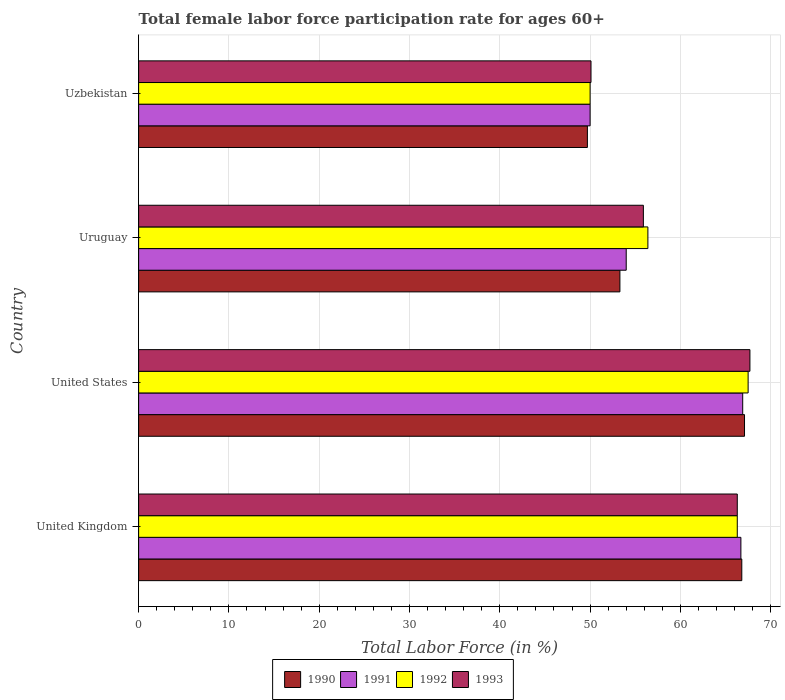Are the number of bars on each tick of the Y-axis equal?
Give a very brief answer. Yes. How many bars are there on the 2nd tick from the top?
Provide a short and direct response. 4. What is the label of the 2nd group of bars from the top?
Keep it short and to the point. Uruguay. In how many cases, is the number of bars for a given country not equal to the number of legend labels?
Provide a succinct answer. 0. What is the female labor force participation rate in 1990 in Uzbekistan?
Your answer should be compact. 49.7. Across all countries, what is the maximum female labor force participation rate in 1993?
Make the answer very short. 67.7. Across all countries, what is the minimum female labor force participation rate in 1993?
Make the answer very short. 50.1. In which country was the female labor force participation rate in 1992 maximum?
Provide a succinct answer. United States. In which country was the female labor force participation rate in 1993 minimum?
Your response must be concise. Uzbekistan. What is the total female labor force participation rate in 1992 in the graph?
Provide a short and direct response. 240.2. What is the difference between the female labor force participation rate in 1993 in United Kingdom and that in United States?
Keep it short and to the point. -1.4. What is the difference between the female labor force participation rate in 1991 in Uzbekistan and the female labor force participation rate in 1990 in United Kingdom?
Provide a short and direct response. -16.8. What is the average female labor force participation rate in 1990 per country?
Make the answer very short. 59.23. What is the difference between the female labor force participation rate in 1990 and female labor force participation rate in 1993 in United States?
Provide a short and direct response. -0.6. What is the ratio of the female labor force participation rate in 1992 in United States to that in Uruguay?
Your answer should be very brief. 1.2. Is the difference between the female labor force participation rate in 1990 in United Kingdom and United States greater than the difference between the female labor force participation rate in 1993 in United Kingdom and United States?
Ensure brevity in your answer.  Yes. What is the difference between the highest and the second highest female labor force participation rate in 1991?
Your answer should be compact. 0.2. What is the difference between the highest and the lowest female labor force participation rate in 1991?
Provide a succinct answer. 16.9. Is it the case that in every country, the sum of the female labor force participation rate in 1993 and female labor force participation rate in 1992 is greater than the sum of female labor force participation rate in 1990 and female labor force participation rate in 1991?
Your response must be concise. No. What does the 1st bar from the top in United Kingdom represents?
Offer a terse response. 1993. Is it the case that in every country, the sum of the female labor force participation rate in 1993 and female labor force participation rate in 1990 is greater than the female labor force participation rate in 1991?
Ensure brevity in your answer.  Yes. How many bars are there?
Provide a short and direct response. 16. What is the difference between two consecutive major ticks on the X-axis?
Offer a terse response. 10. Does the graph contain grids?
Your response must be concise. Yes. Where does the legend appear in the graph?
Offer a very short reply. Bottom center. How many legend labels are there?
Your answer should be compact. 4. What is the title of the graph?
Your answer should be very brief. Total female labor force participation rate for ages 60+. Does "1960" appear as one of the legend labels in the graph?
Your response must be concise. No. What is the Total Labor Force (in %) of 1990 in United Kingdom?
Ensure brevity in your answer.  66.8. What is the Total Labor Force (in %) of 1991 in United Kingdom?
Provide a succinct answer. 66.7. What is the Total Labor Force (in %) in 1992 in United Kingdom?
Make the answer very short. 66.3. What is the Total Labor Force (in %) of 1993 in United Kingdom?
Your response must be concise. 66.3. What is the Total Labor Force (in %) of 1990 in United States?
Your answer should be compact. 67.1. What is the Total Labor Force (in %) in 1991 in United States?
Your answer should be very brief. 66.9. What is the Total Labor Force (in %) of 1992 in United States?
Ensure brevity in your answer.  67.5. What is the Total Labor Force (in %) in 1993 in United States?
Offer a terse response. 67.7. What is the Total Labor Force (in %) in 1990 in Uruguay?
Make the answer very short. 53.3. What is the Total Labor Force (in %) of 1992 in Uruguay?
Offer a terse response. 56.4. What is the Total Labor Force (in %) of 1993 in Uruguay?
Your answer should be very brief. 55.9. What is the Total Labor Force (in %) in 1990 in Uzbekistan?
Offer a terse response. 49.7. What is the Total Labor Force (in %) of 1993 in Uzbekistan?
Keep it short and to the point. 50.1. Across all countries, what is the maximum Total Labor Force (in %) in 1990?
Offer a very short reply. 67.1. Across all countries, what is the maximum Total Labor Force (in %) of 1991?
Your answer should be compact. 66.9. Across all countries, what is the maximum Total Labor Force (in %) in 1992?
Provide a succinct answer. 67.5. Across all countries, what is the maximum Total Labor Force (in %) in 1993?
Provide a short and direct response. 67.7. Across all countries, what is the minimum Total Labor Force (in %) of 1990?
Ensure brevity in your answer.  49.7. Across all countries, what is the minimum Total Labor Force (in %) in 1991?
Make the answer very short. 50. Across all countries, what is the minimum Total Labor Force (in %) in 1993?
Ensure brevity in your answer.  50.1. What is the total Total Labor Force (in %) of 1990 in the graph?
Provide a short and direct response. 236.9. What is the total Total Labor Force (in %) of 1991 in the graph?
Offer a terse response. 237.6. What is the total Total Labor Force (in %) of 1992 in the graph?
Your answer should be compact. 240.2. What is the total Total Labor Force (in %) of 1993 in the graph?
Keep it short and to the point. 240. What is the difference between the Total Labor Force (in %) of 1990 in United Kingdom and that in United States?
Provide a short and direct response. -0.3. What is the difference between the Total Labor Force (in %) of 1991 in United Kingdom and that in United States?
Your answer should be very brief. -0.2. What is the difference between the Total Labor Force (in %) in 1993 in United Kingdom and that in United States?
Provide a short and direct response. -1.4. What is the difference between the Total Labor Force (in %) of 1990 in United Kingdom and that in Uruguay?
Your answer should be compact. 13.5. What is the difference between the Total Labor Force (in %) in 1992 in United Kingdom and that in Uruguay?
Provide a succinct answer. 9.9. What is the difference between the Total Labor Force (in %) in 1993 in United Kingdom and that in Uruguay?
Give a very brief answer. 10.4. What is the difference between the Total Labor Force (in %) in 1990 in United Kingdom and that in Uzbekistan?
Keep it short and to the point. 17.1. What is the difference between the Total Labor Force (in %) of 1992 in United Kingdom and that in Uzbekistan?
Provide a short and direct response. 16.3. What is the difference between the Total Labor Force (in %) in 1993 in United Kingdom and that in Uzbekistan?
Offer a very short reply. 16.2. What is the difference between the Total Labor Force (in %) of 1990 in United States and that in Uruguay?
Provide a short and direct response. 13.8. What is the difference between the Total Labor Force (in %) of 1992 in United States and that in Uruguay?
Your response must be concise. 11.1. What is the difference between the Total Labor Force (in %) in 1990 in United States and that in Uzbekistan?
Make the answer very short. 17.4. What is the difference between the Total Labor Force (in %) of 1990 in Uruguay and that in Uzbekistan?
Offer a terse response. 3.6. What is the difference between the Total Labor Force (in %) in 1993 in Uruguay and that in Uzbekistan?
Give a very brief answer. 5.8. What is the difference between the Total Labor Force (in %) in 1990 in United Kingdom and the Total Labor Force (in %) in 1991 in United States?
Offer a very short reply. -0.1. What is the difference between the Total Labor Force (in %) in 1990 in United Kingdom and the Total Labor Force (in %) in 1993 in United States?
Make the answer very short. -0.9. What is the difference between the Total Labor Force (in %) in 1991 in United Kingdom and the Total Labor Force (in %) in 1993 in United States?
Your answer should be compact. -1. What is the difference between the Total Labor Force (in %) in 1992 in United Kingdom and the Total Labor Force (in %) in 1993 in United States?
Your answer should be compact. -1.4. What is the difference between the Total Labor Force (in %) of 1991 in United Kingdom and the Total Labor Force (in %) of 1993 in Uruguay?
Your answer should be compact. 10.8. What is the difference between the Total Labor Force (in %) of 1990 in United Kingdom and the Total Labor Force (in %) of 1991 in Uzbekistan?
Provide a succinct answer. 16.8. What is the difference between the Total Labor Force (in %) of 1990 in United Kingdom and the Total Labor Force (in %) of 1993 in Uzbekistan?
Your response must be concise. 16.7. What is the difference between the Total Labor Force (in %) of 1991 in United Kingdom and the Total Labor Force (in %) of 1992 in Uzbekistan?
Keep it short and to the point. 16.7. What is the difference between the Total Labor Force (in %) in 1992 in United Kingdom and the Total Labor Force (in %) in 1993 in Uzbekistan?
Offer a terse response. 16.2. What is the difference between the Total Labor Force (in %) of 1990 in United States and the Total Labor Force (in %) of 1992 in Uruguay?
Keep it short and to the point. 10.7. What is the difference between the Total Labor Force (in %) in 1990 in United States and the Total Labor Force (in %) in 1991 in Uzbekistan?
Your answer should be very brief. 17.1. What is the difference between the Total Labor Force (in %) in 1990 in United States and the Total Labor Force (in %) in 1992 in Uzbekistan?
Offer a very short reply. 17.1. What is the difference between the Total Labor Force (in %) of 1991 in United States and the Total Labor Force (in %) of 1993 in Uzbekistan?
Make the answer very short. 16.8. What is the difference between the Total Labor Force (in %) in 1990 in Uruguay and the Total Labor Force (in %) in 1993 in Uzbekistan?
Provide a short and direct response. 3.2. What is the difference between the Total Labor Force (in %) in 1991 in Uruguay and the Total Labor Force (in %) in 1993 in Uzbekistan?
Offer a very short reply. 3.9. What is the average Total Labor Force (in %) of 1990 per country?
Make the answer very short. 59.23. What is the average Total Labor Force (in %) of 1991 per country?
Ensure brevity in your answer.  59.4. What is the average Total Labor Force (in %) of 1992 per country?
Offer a terse response. 60.05. What is the average Total Labor Force (in %) in 1993 per country?
Ensure brevity in your answer.  60. What is the difference between the Total Labor Force (in %) of 1991 and Total Labor Force (in %) of 1993 in United Kingdom?
Provide a succinct answer. 0.4. What is the difference between the Total Labor Force (in %) of 1990 and Total Labor Force (in %) of 1992 in United States?
Ensure brevity in your answer.  -0.4. What is the difference between the Total Labor Force (in %) in 1990 and Total Labor Force (in %) in 1993 in United States?
Offer a terse response. -0.6. What is the difference between the Total Labor Force (in %) in 1991 and Total Labor Force (in %) in 1992 in United States?
Make the answer very short. -0.6. What is the difference between the Total Labor Force (in %) in 1992 and Total Labor Force (in %) in 1993 in United States?
Your answer should be very brief. -0.2. What is the difference between the Total Labor Force (in %) in 1990 and Total Labor Force (in %) in 1991 in Uruguay?
Provide a short and direct response. -0.7. What is the difference between the Total Labor Force (in %) of 1990 and Total Labor Force (in %) of 1992 in Uruguay?
Keep it short and to the point. -3.1. What is the difference between the Total Labor Force (in %) of 1990 and Total Labor Force (in %) of 1993 in Uruguay?
Make the answer very short. -2.6. What is the difference between the Total Labor Force (in %) in 1991 and Total Labor Force (in %) in 1992 in Uruguay?
Your answer should be very brief. -2.4. What is the difference between the Total Labor Force (in %) in 1992 and Total Labor Force (in %) in 1993 in Uruguay?
Offer a very short reply. 0.5. What is the difference between the Total Labor Force (in %) in 1990 and Total Labor Force (in %) in 1991 in Uzbekistan?
Your answer should be compact. -0.3. What is the difference between the Total Labor Force (in %) of 1990 and Total Labor Force (in %) of 1992 in Uzbekistan?
Ensure brevity in your answer.  -0.3. What is the difference between the Total Labor Force (in %) of 1991 and Total Labor Force (in %) of 1993 in Uzbekistan?
Your answer should be compact. -0.1. What is the ratio of the Total Labor Force (in %) in 1990 in United Kingdom to that in United States?
Your response must be concise. 1. What is the ratio of the Total Labor Force (in %) in 1992 in United Kingdom to that in United States?
Make the answer very short. 0.98. What is the ratio of the Total Labor Force (in %) in 1993 in United Kingdom to that in United States?
Give a very brief answer. 0.98. What is the ratio of the Total Labor Force (in %) in 1990 in United Kingdom to that in Uruguay?
Your answer should be compact. 1.25. What is the ratio of the Total Labor Force (in %) in 1991 in United Kingdom to that in Uruguay?
Give a very brief answer. 1.24. What is the ratio of the Total Labor Force (in %) in 1992 in United Kingdom to that in Uruguay?
Offer a terse response. 1.18. What is the ratio of the Total Labor Force (in %) of 1993 in United Kingdom to that in Uruguay?
Offer a terse response. 1.19. What is the ratio of the Total Labor Force (in %) in 1990 in United Kingdom to that in Uzbekistan?
Offer a terse response. 1.34. What is the ratio of the Total Labor Force (in %) of 1991 in United Kingdom to that in Uzbekistan?
Provide a short and direct response. 1.33. What is the ratio of the Total Labor Force (in %) in 1992 in United Kingdom to that in Uzbekistan?
Your answer should be compact. 1.33. What is the ratio of the Total Labor Force (in %) of 1993 in United Kingdom to that in Uzbekistan?
Keep it short and to the point. 1.32. What is the ratio of the Total Labor Force (in %) in 1990 in United States to that in Uruguay?
Provide a short and direct response. 1.26. What is the ratio of the Total Labor Force (in %) in 1991 in United States to that in Uruguay?
Provide a succinct answer. 1.24. What is the ratio of the Total Labor Force (in %) of 1992 in United States to that in Uruguay?
Ensure brevity in your answer.  1.2. What is the ratio of the Total Labor Force (in %) in 1993 in United States to that in Uruguay?
Provide a short and direct response. 1.21. What is the ratio of the Total Labor Force (in %) of 1990 in United States to that in Uzbekistan?
Offer a terse response. 1.35. What is the ratio of the Total Labor Force (in %) of 1991 in United States to that in Uzbekistan?
Give a very brief answer. 1.34. What is the ratio of the Total Labor Force (in %) in 1992 in United States to that in Uzbekistan?
Your response must be concise. 1.35. What is the ratio of the Total Labor Force (in %) in 1993 in United States to that in Uzbekistan?
Make the answer very short. 1.35. What is the ratio of the Total Labor Force (in %) in 1990 in Uruguay to that in Uzbekistan?
Your response must be concise. 1.07. What is the ratio of the Total Labor Force (in %) of 1991 in Uruguay to that in Uzbekistan?
Your answer should be very brief. 1.08. What is the ratio of the Total Labor Force (in %) of 1992 in Uruguay to that in Uzbekistan?
Make the answer very short. 1.13. What is the ratio of the Total Labor Force (in %) of 1993 in Uruguay to that in Uzbekistan?
Make the answer very short. 1.12. What is the difference between the highest and the second highest Total Labor Force (in %) in 1991?
Your answer should be compact. 0.2. What is the difference between the highest and the lowest Total Labor Force (in %) in 1991?
Offer a very short reply. 16.9. What is the difference between the highest and the lowest Total Labor Force (in %) of 1992?
Offer a terse response. 17.5. 